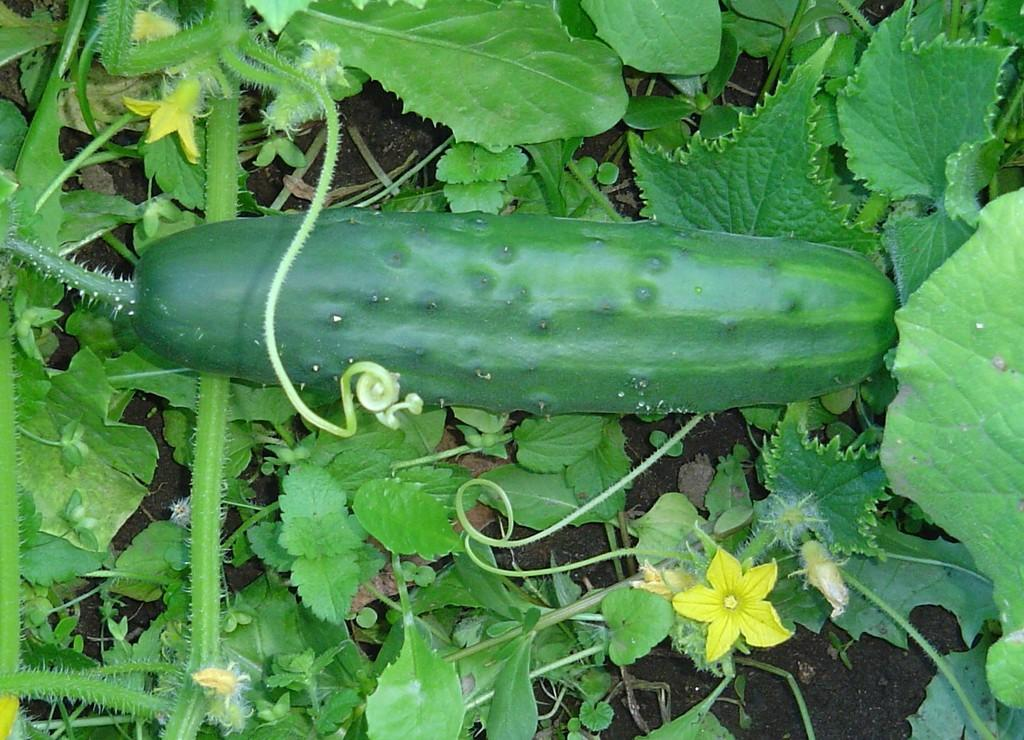What type of vegetable can be seen in the image that resembles a cucumber? There is a vegetable in the image that resembles a cucumber. What kind of plant is present in the image? There is a creeper plant in the image. What color are the flowers on the creeper plant? The creeper plant has yellow flowers. How many frogs are sitting on the pear in the image? There is no pear or frogs present in the image. 